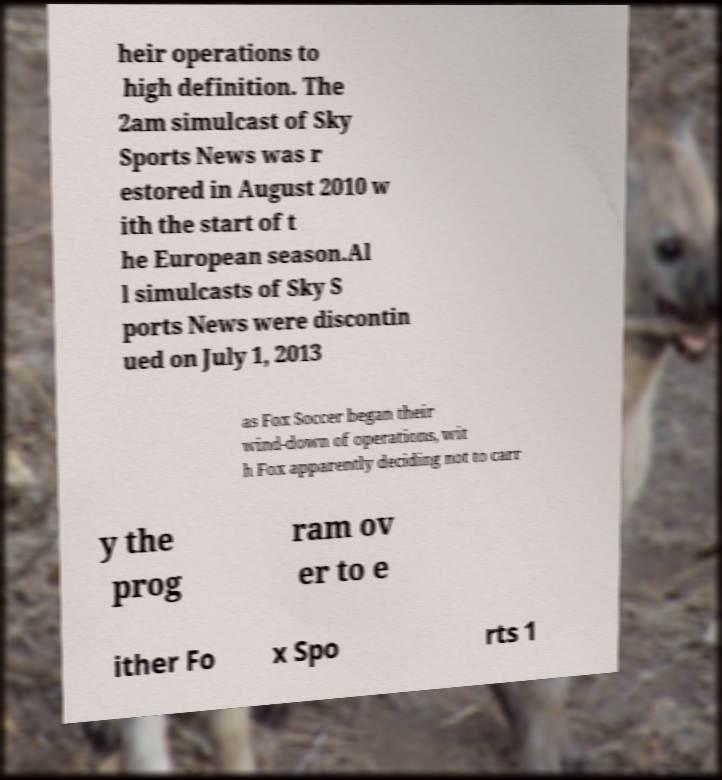There's text embedded in this image that I need extracted. Can you transcribe it verbatim? heir operations to high definition. The 2am simulcast of Sky Sports News was r estored in August 2010 w ith the start of t he European season.Al l simulcasts of Sky S ports News were discontin ued on July 1, 2013 as Fox Soccer began their wind-down of operations, wit h Fox apparently deciding not to carr y the prog ram ov er to e ither Fo x Spo rts 1 